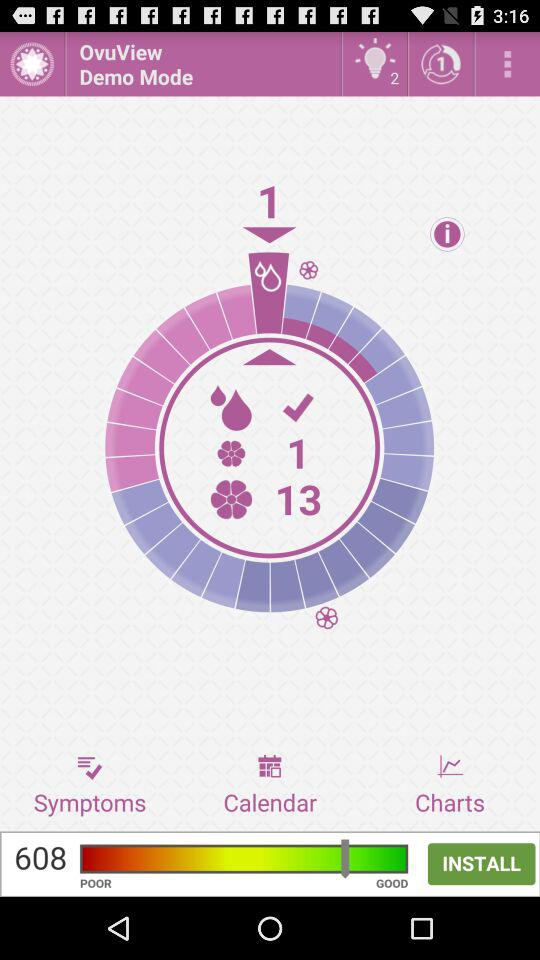On which day of the calendar did the ovulation begin?
When the provided information is insufficient, respond with <no answer>. <no answer> 